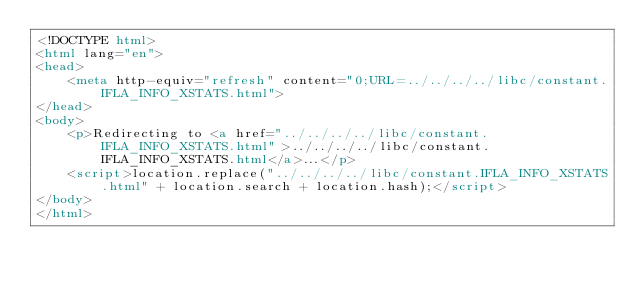Convert code to text. <code><loc_0><loc_0><loc_500><loc_500><_HTML_><!DOCTYPE html>
<html lang="en">
<head>
    <meta http-equiv="refresh" content="0;URL=../../../../libc/constant.IFLA_INFO_XSTATS.html">
</head>
<body>
    <p>Redirecting to <a href="../../../../libc/constant.IFLA_INFO_XSTATS.html">../../../../libc/constant.IFLA_INFO_XSTATS.html</a>...</p>
    <script>location.replace("../../../../libc/constant.IFLA_INFO_XSTATS.html" + location.search + location.hash);</script>
</body>
</html></code> 